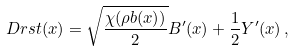<formula> <loc_0><loc_0><loc_500><loc_500>\ D r s t ( x ) = \sqrt { \frac { \chi ( \rho b ( x ) ) } 2 } B ^ { \prime } ( x ) + \frac { 1 } { 2 } Y ^ { \prime } ( x ) \, ,</formula> 